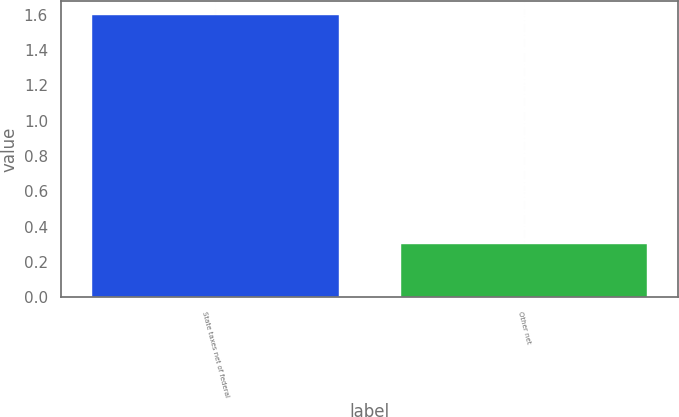<chart> <loc_0><loc_0><loc_500><loc_500><bar_chart><fcel>State taxes net of federal<fcel>Other net<nl><fcel>1.6<fcel>0.3<nl></chart> 